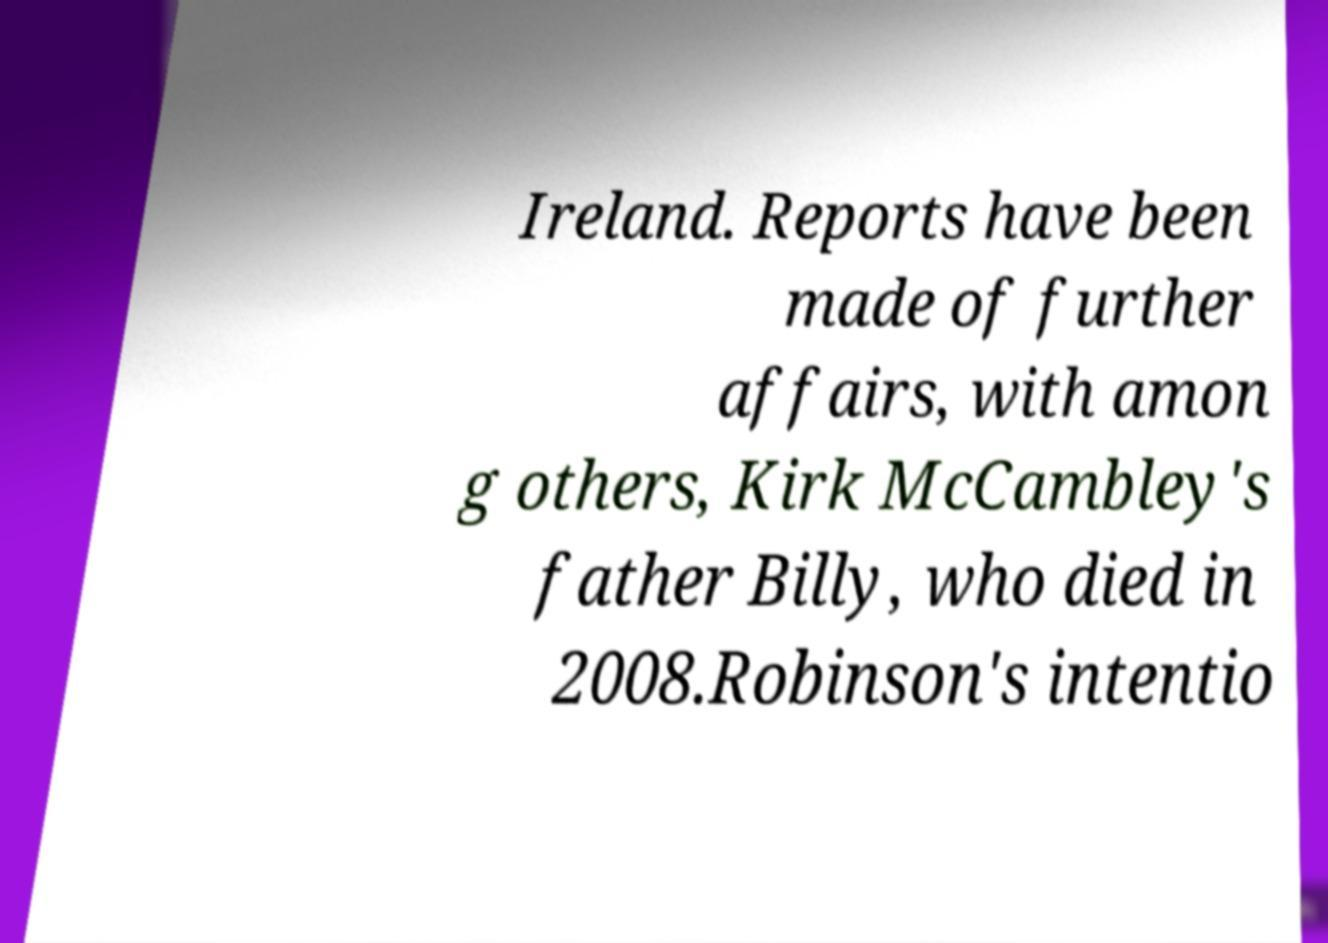Please identify and transcribe the text found in this image. Ireland. Reports have been made of further affairs, with amon g others, Kirk McCambley's father Billy, who died in 2008.Robinson's intentio 